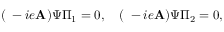Convert formula to latex. <formula><loc_0><loc_0><loc_500><loc_500>( \nabla - i e A ) \Psi \Pi _ { 1 } = 0 , \quad ( \nabla - i e A ) \Psi \Pi _ { 2 } = 0 ,</formula> 